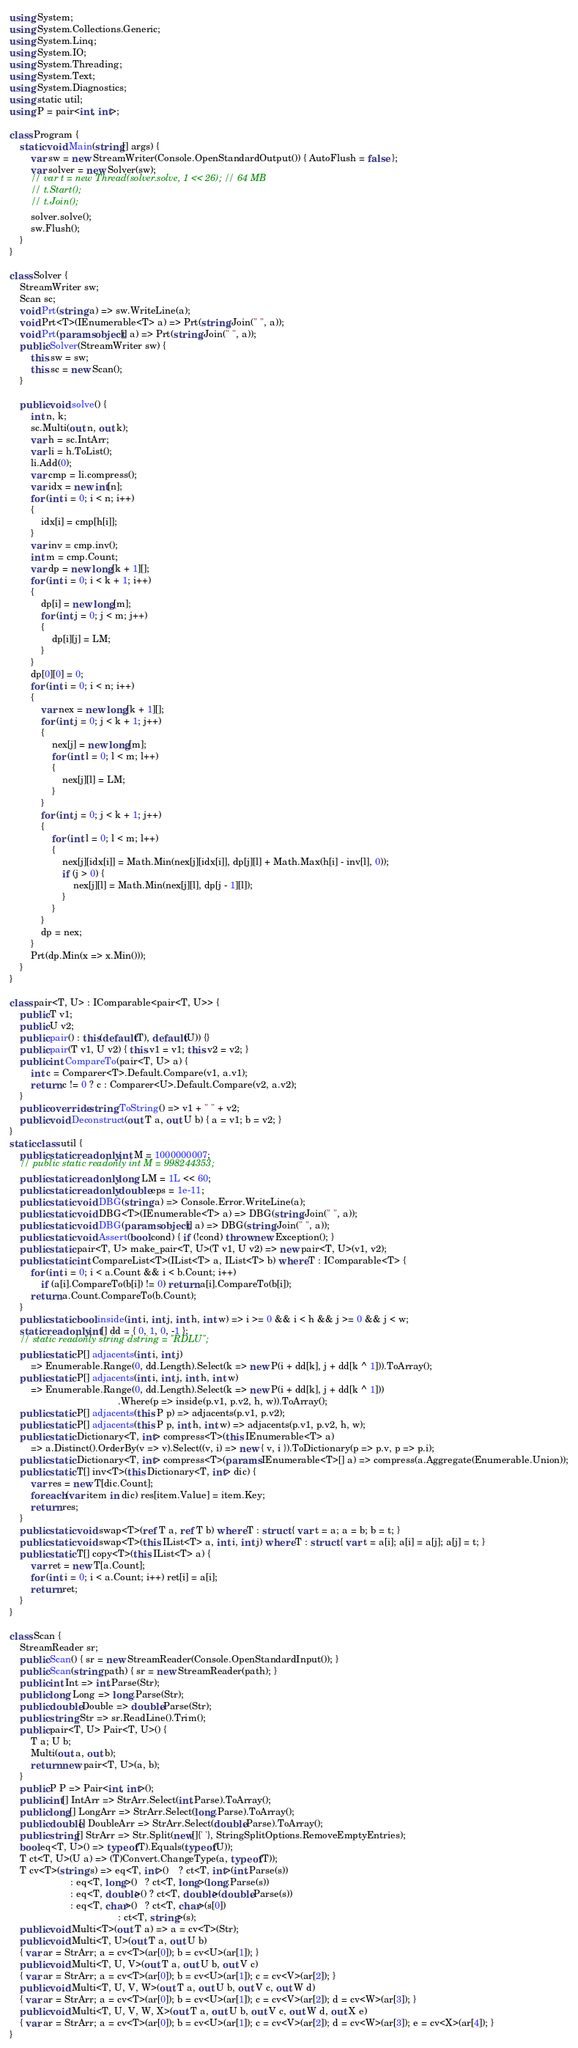<code> <loc_0><loc_0><loc_500><loc_500><_C#_>using System;
using System.Collections.Generic;
using System.Linq;
using System.IO;
using System.Threading;
using System.Text;
using System.Diagnostics;
using static util;
using P = pair<int, int>;

class Program {
    static void Main(string[] args) {
        var sw = new StreamWriter(Console.OpenStandardOutput()) { AutoFlush = false };
        var solver = new Solver(sw);
        // var t = new Thread(solver.solve, 1 << 26); // 64 MB
        // t.Start();
        // t.Join();
        solver.solve();
        sw.Flush();
    }
}

class Solver {
    StreamWriter sw;
    Scan sc;
    void Prt(string a) => sw.WriteLine(a);
    void Prt<T>(IEnumerable<T> a) => Prt(string.Join(" ", a));
    void Prt(params object[] a) => Prt(string.Join(" ", a));
    public Solver(StreamWriter sw) {
        this.sw = sw;
        this.sc = new Scan();
    }

    public void solve() {
        int n, k;
        sc.Multi(out n, out k);
        var h = sc.IntArr;
        var li = h.ToList();
        li.Add(0);
        var cmp = li.compress();
        var idx = new int[n];
        for (int i = 0; i < n; i++)
        {
            idx[i] = cmp[h[i]];
        }
        var inv = cmp.inv();
        int m = cmp.Count;
        var dp = new long[k + 1][];
        for (int i = 0; i < k + 1; i++)
        {
            dp[i] = new long[m];
            for (int j = 0; j < m; j++)
            {
                dp[i][j] = LM;
            }
        }
        dp[0][0] = 0;
        for (int i = 0; i < n; i++)
        {
            var nex = new long[k + 1][];
            for (int j = 0; j < k + 1; j++)
            {
                nex[j] = new long[m];
                for (int l = 0; l < m; l++)
                {
                    nex[j][l] = LM;
                }
            }
            for (int j = 0; j < k + 1; j++)
            {
                for (int l = 0; l < m; l++)
                {
                    nex[j][idx[i]] = Math.Min(nex[j][idx[i]], dp[j][l] + Math.Max(h[i] - inv[l], 0));
                    if (j > 0) {
                        nex[j][l] = Math.Min(nex[j][l], dp[j - 1][l]);
                    }
                }
            }
            dp = nex;
        }
        Prt(dp.Min(x => x.Min()));
    }
}

class pair<T, U> : IComparable<pair<T, U>> {
    public T v1;
    public U v2;
    public pair() : this(default(T), default(U)) {}
    public pair(T v1, U v2) { this.v1 = v1; this.v2 = v2; }
    public int CompareTo(pair<T, U> a) {
        int c = Comparer<T>.Default.Compare(v1, a.v1);
        return c != 0 ? c : Comparer<U>.Default.Compare(v2, a.v2);
    }
    public override string ToString() => v1 + " " + v2;
    public void Deconstruct(out T a, out U b) { a = v1; b = v2; }
}
static class util {
    public static readonly int M = 1000000007;
    // public static readonly int M = 998244353;
    public static readonly long LM = 1L << 60;
    public static readonly double eps = 1e-11;
    public static void DBG(string a) => Console.Error.WriteLine(a);
    public static void DBG<T>(IEnumerable<T> a) => DBG(string.Join(" ", a));
    public static void DBG(params object[] a) => DBG(string.Join(" ", a));
    public static void Assert(bool cond) { if (!cond) throw new Exception(); }
    public static pair<T, U> make_pair<T, U>(T v1, U v2) => new pair<T, U>(v1, v2);
    public static int CompareList<T>(IList<T> a, IList<T> b) where T : IComparable<T> {
        for (int i = 0; i < a.Count && i < b.Count; i++)
            if (a[i].CompareTo(b[i]) != 0) return a[i].CompareTo(b[i]);
        return a.Count.CompareTo(b.Count);
    }
    public static bool inside(int i, int j, int h, int w) => i >= 0 && i < h && j >= 0 && j < w;
    static readonly int[] dd = { 0, 1, 0, -1 };
    // static readonly string dstring = "RDLU";
    public static P[] adjacents(int i, int j)
        => Enumerable.Range(0, dd.Length).Select(k => new P(i + dd[k], j + dd[k ^ 1])).ToArray();
    public static P[] adjacents(int i, int j, int h, int w)
        => Enumerable.Range(0, dd.Length).Select(k => new P(i + dd[k], j + dd[k ^ 1]))
                                         .Where(p => inside(p.v1, p.v2, h, w)).ToArray();
    public static P[] adjacents(this P p) => adjacents(p.v1, p.v2);
    public static P[] adjacents(this P p, int h, int w) => adjacents(p.v1, p.v2, h, w);
    public static Dictionary<T, int> compress<T>(this IEnumerable<T> a)
        => a.Distinct().OrderBy(v => v).Select((v, i) => new { v, i }).ToDictionary(p => p.v, p => p.i);
    public static Dictionary<T, int> compress<T>(params IEnumerable<T>[] a) => compress(a.Aggregate(Enumerable.Union));
    public static T[] inv<T>(this Dictionary<T, int> dic) {
        var res = new T[dic.Count];
        foreach (var item in dic) res[item.Value] = item.Key;
        return res;
    }
    public static void swap<T>(ref T a, ref T b) where T : struct { var t = a; a = b; b = t; }
    public static void swap<T>(this IList<T> a, int i, int j) where T : struct { var t = a[i]; a[i] = a[j]; a[j] = t; }
    public static T[] copy<T>(this IList<T> a) {
        var ret = new T[a.Count];
        for (int i = 0; i < a.Count; i++) ret[i] = a[i];
        return ret;
    }
}

class Scan {
    StreamReader sr;
    public Scan() { sr = new StreamReader(Console.OpenStandardInput()); }
    public Scan(string path) { sr = new StreamReader(path); }
    public int Int => int.Parse(Str);
    public long Long => long.Parse(Str);
    public double Double => double.Parse(Str);
    public string Str => sr.ReadLine().Trim();
    public pair<T, U> Pair<T, U>() {
        T a; U b;
        Multi(out a, out b);
        return new pair<T, U>(a, b);
    }
    public P P => Pair<int, int>();
    public int[] IntArr => StrArr.Select(int.Parse).ToArray();
    public long[] LongArr => StrArr.Select(long.Parse).ToArray();
    public double[] DoubleArr => StrArr.Select(double.Parse).ToArray();
    public string[] StrArr => Str.Split(new[]{' '}, StringSplitOptions.RemoveEmptyEntries);
    bool eq<T, U>() => typeof(T).Equals(typeof(U));
    T ct<T, U>(U a) => (T)Convert.ChangeType(a, typeof(T));
    T cv<T>(string s) => eq<T, int>()    ? ct<T, int>(int.Parse(s))
                       : eq<T, long>()   ? ct<T, long>(long.Parse(s))
                       : eq<T, double>() ? ct<T, double>(double.Parse(s))
                       : eq<T, char>()   ? ct<T, char>(s[0])
                                         : ct<T, string>(s);
    public void Multi<T>(out T a) => a = cv<T>(Str);
    public void Multi<T, U>(out T a, out U b)
    { var ar = StrArr; a = cv<T>(ar[0]); b = cv<U>(ar[1]); }
    public void Multi<T, U, V>(out T a, out U b, out V c)
    { var ar = StrArr; a = cv<T>(ar[0]); b = cv<U>(ar[1]); c = cv<V>(ar[2]); }
    public void Multi<T, U, V, W>(out T a, out U b, out V c, out W d)
    { var ar = StrArr; a = cv<T>(ar[0]); b = cv<U>(ar[1]); c = cv<V>(ar[2]); d = cv<W>(ar[3]); }
    public void Multi<T, U, V, W, X>(out T a, out U b, out V c, out W d, out X e)
    { var ar = StrArr; a = cv<T>(ar[0]); b = cv<U>(ar[1]); c = cv<V>(ar[2]); d = cv<W>(ar[3]); e = cv<X>(ar[4]); }
}
</code> 